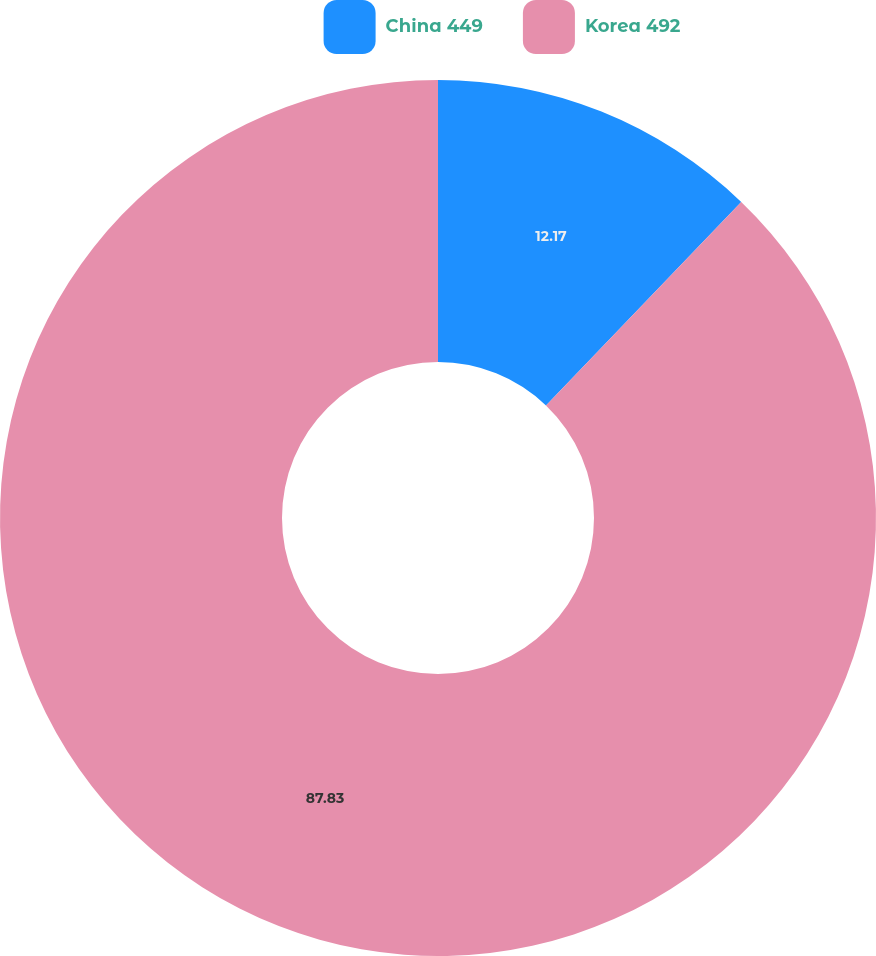Convert chart to OTSL. <chart><loc_0><loc_0><loc_500><loc_500><pie_chart><fcel>China 449<fcel>Korea 492<nl><fcel>12.17%<fcel>87.83%<nl></chart> 